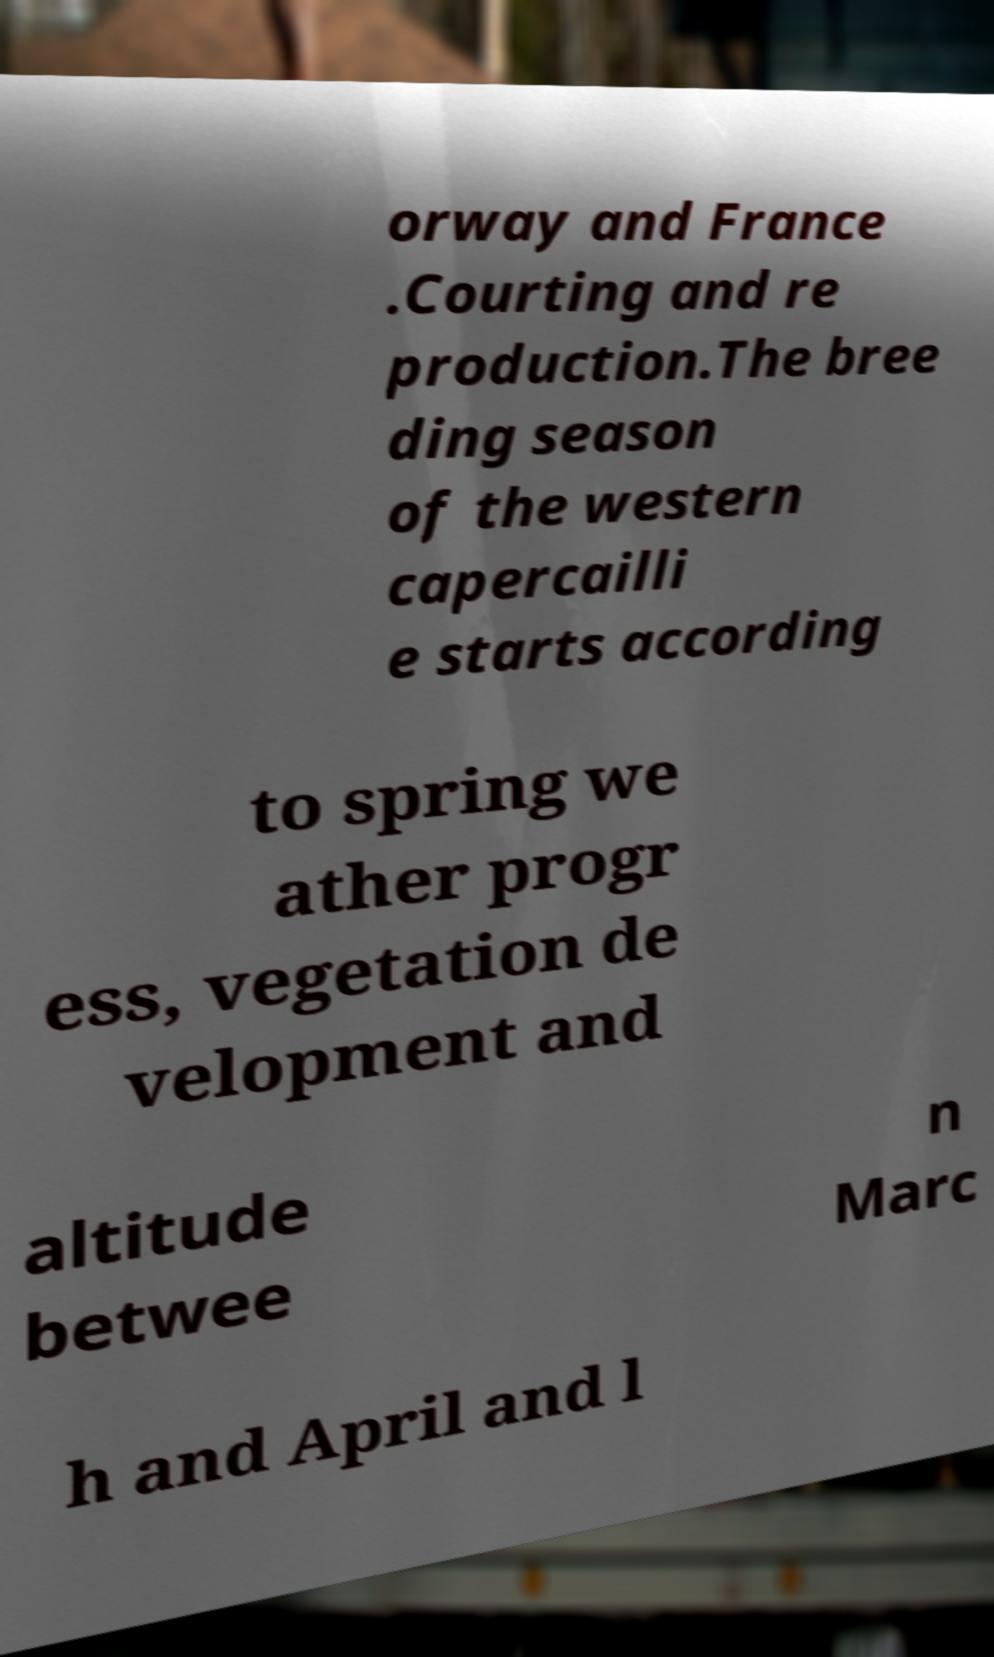What messages or text are displayed in this image? I need them in a readable, typed format. orway and France .Courting and re production.The bree ding season of the western capercailli e starts according to spring we ather progr ess, vegetation de velopment and altitude betwee n Marc h and April and l 